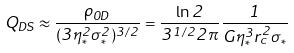<formula> <loc_0><loc_0><loc_500><loc_500>Q _ { D S } \approx \frac { \rho _ { 0 D } } { ( 3 \eta _ { * } ^ { 2 } \sigma _ { * } ^ { 2 } ) ^ { 3 / 2 } } = \frac { \ln { 2 } } { 3 ^ { 1 / 2 } 2 \pi } \frac { 1 } { G \eta _ { * } ^ { 3 } r _ { c } ^ { 2 } \sigma _ { * } }</formula> 